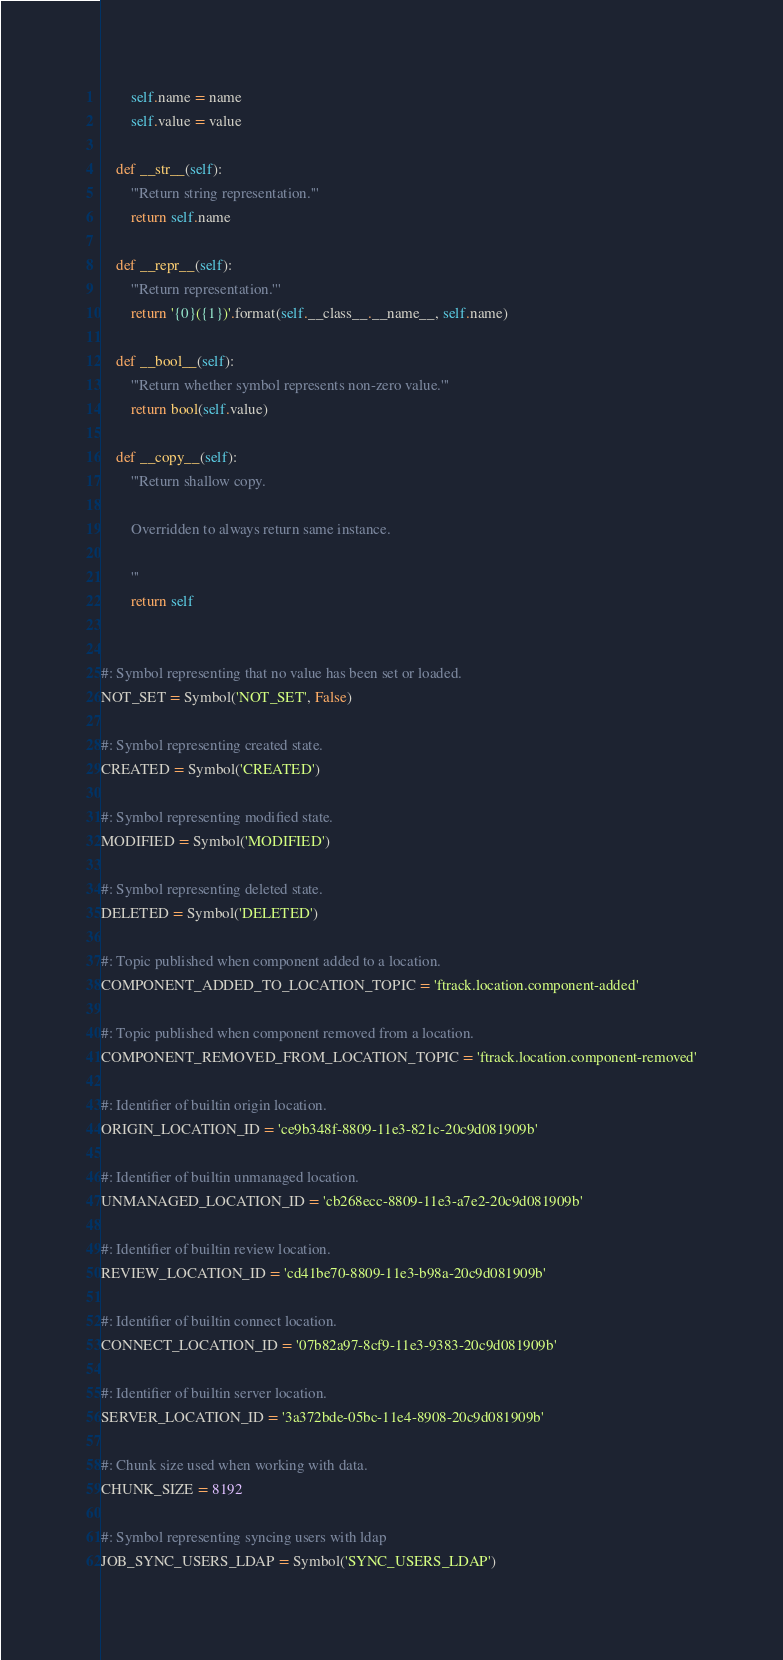Convert code to text. <code><loc_0><loc_0><loc_500><loc_500><_Python_>        self.name = name
        self.value = value

    def __str__(self):
        '''Return string representation.'''
        return self.name

    def __repr__(self):
        '''Return representation.'''
        return '{0}({1})'.format(self.__class__.__name__, self.name)

    def __bool__(self):
        '''Return whether symbol represents non-zero value.'''
        return bool(self.value)

    def __copy__(self):
        '''Return shallow copy.

        Overridden to always return same instance.

        '''
        return self


#: Symbol representing that no value has been set or loaded.
NOT_SET = Symbol('NOT_SET', False)

#: Symbol representing created state.
CREATED = Symbol('CREATED')

#: Symbol representing modified state.
MODIFIED = Symbol('MODIFIED')

#: Symbol representing deleted state.
DELETED = Symbol('DELETED')

#: Topic published when component added to a location.
COMPONENT_ADDED_TO_LOCATION_TOPIC = 'ftrack.location.component-added'

#: Topic published when component removed from a location.
COMPONENT_REMOVED_FROM_LOCATION_TOPIC = 'ftrack.location.component-removed'

#: Identifier of builtin origin location.
ORIGIN_LOCATION_ID = 'ce9b348f-8809-11e3-821c-20c9d081909b'

#: Identifier of builtin unmanaged location.
UNMANAGED_LOCATION_ID = 'cb268ecc-8809-11e3-a7e2-20c9d081909b'

#: Identifier of builtin review location.
REVIEW_LOCATION_ID = 'cd41be70-8809-11e3-b98a-20c9d081909b'

#: Identifier of builtin connect location.
CONNECT_LOCATION_ID = '07b82a97-8cf9-11e3-9383-20c9d081909b'

#: Identifier of builtin server location.
SERVER_LOCATION_ID = '3a372bde-05bc-11e4-8908-20c9d081909b'

#: Chunk size used when working with data.
CHUNK_SIZE = 8192

#: Symbol representing syncing users with ldap
JOB_SYNC_USERS_LDAP = Symbol('SYNC_USERS_LDAP')
</code> 